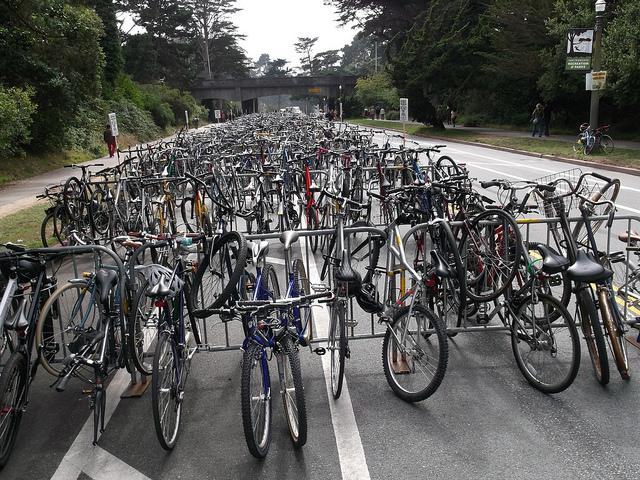What type of transportation is shown?

Choices:
A) air
B) rail
C) road
D) water road 